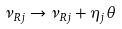<formula> <loc_0><loc_0><loc_500><loc_500>\nu _ { R j } \rightarrow \nu _ { R j } + \eta _ { j } \theta</formula> 